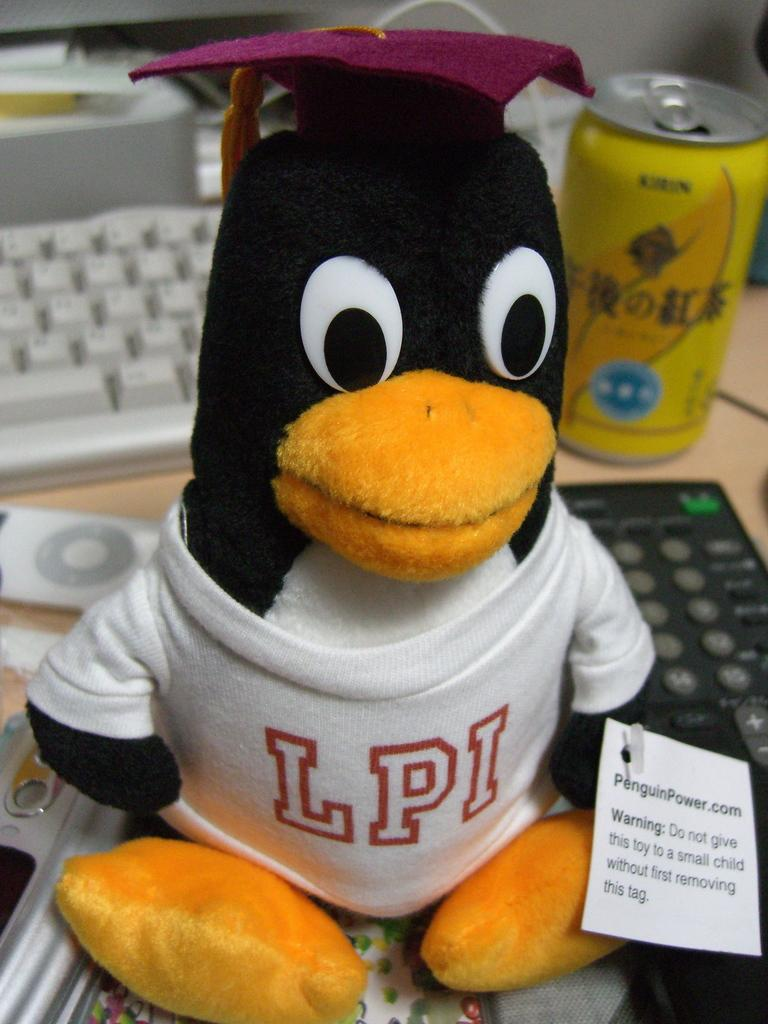What type of toy is present in the image? There is a toy penguin with a shirt and a hat in the image. What other objects can be seen in the image? There are remotes, a tin, and a keyboard in the image. Where are these objects located? They are on a table in the image. How does the toy penguin react to the remote in the image? The toy penguin does not react to the remote in the image, as it is an inanimate object. 